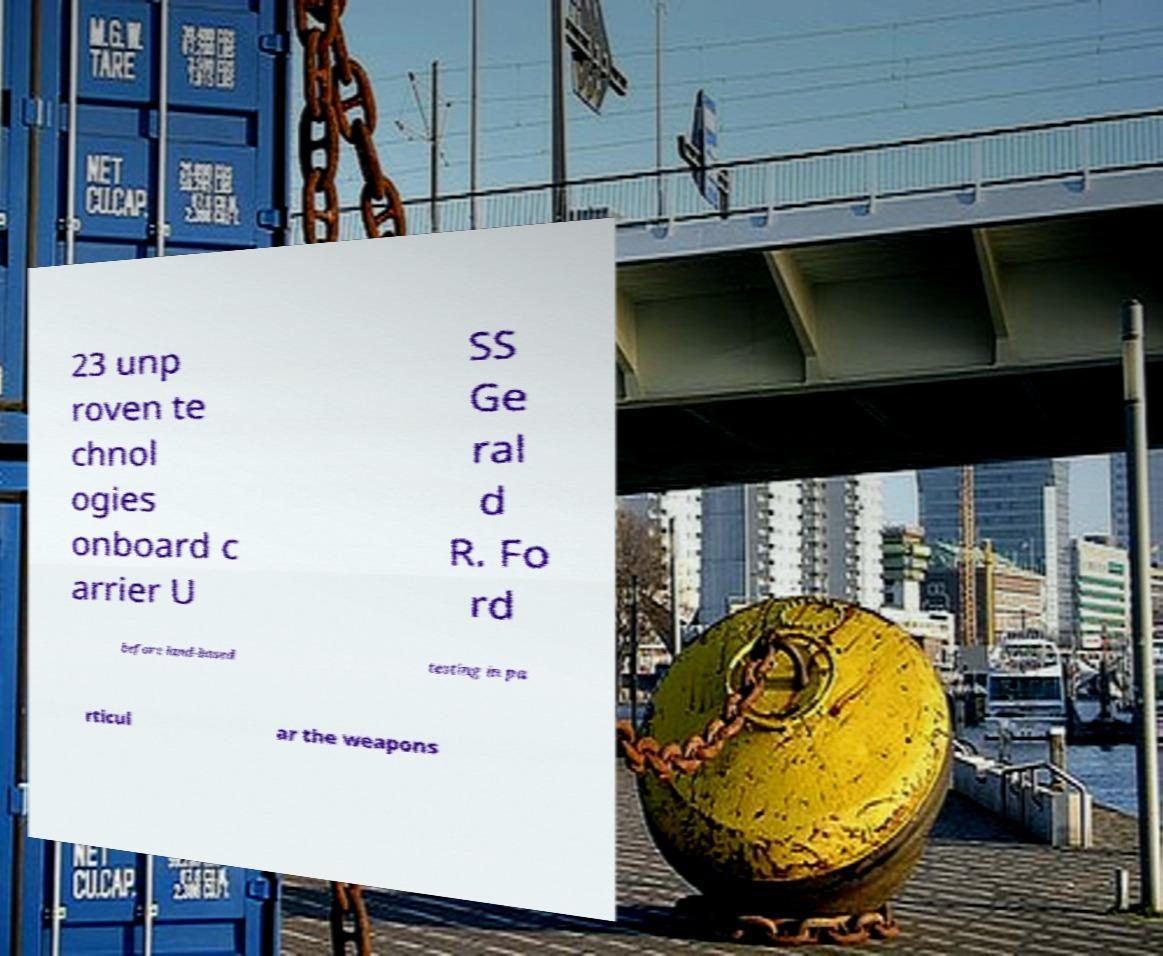Could you extract and type out the text from this image? 23 unp roven te chnol ogies onboard c arrier U SS Ge ral d R. Fo rd before land-based testing in pa rticul ar the weapons 